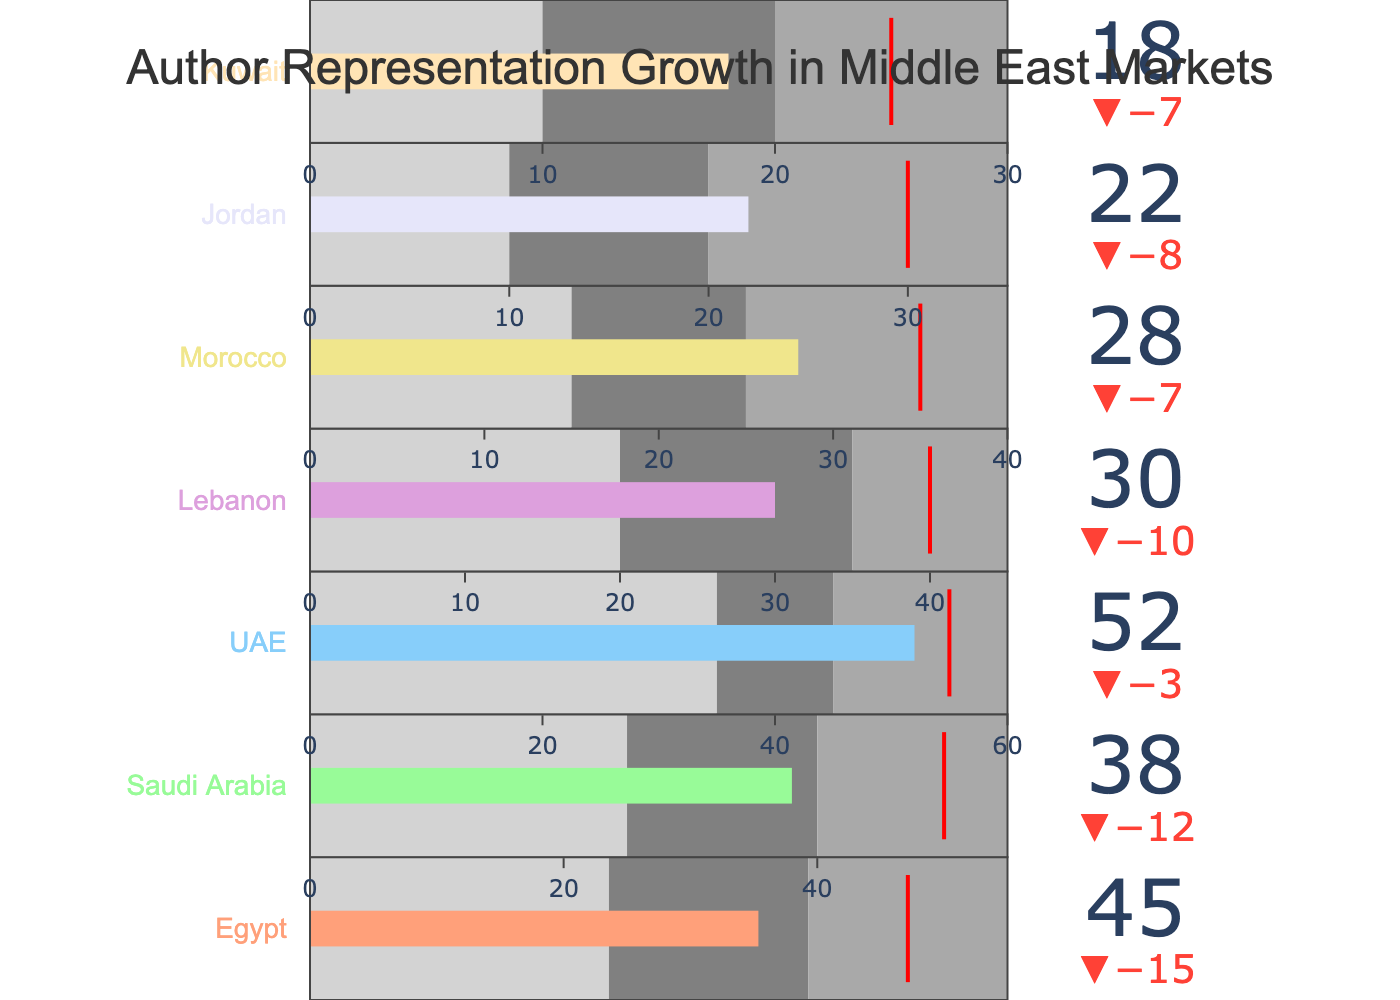What is the title of the bullet chart? The title of the chart is usually displayed at the top and provides information about the overall topic of the chart. In this case, the title tells us what the chart is about.
Answer: Author Representation Growth in Middle East Markets Which country has the highest actual value? By looking at the actual values (the bullet points), we can see which one is the highest among the countries listed.
Answer: UAE What is the target value for Egypt? The target value for each country is shown with a red line or threshold on the bullet chart. For Egypt, this target can be easily located by looking at its section in the chart.
Answer: 60 Which countries have reached their target values? We compare the actual values with the target values for each country. If the actual value is equal to or greater than the target value, the target is considered reached.
Answer: UAE What is the difference between the actual and target values for Saudi Arabia? Subtract Saudi Arabia's actual value from its target value to find the difference.
Answer: 12 How many countries have an actual value greater than 30? Count the number of countries where the actual value exceeds 30.
Answer: 4 Which country has the smallest difference between its actual and target value? Subtract the actual value from the target value for each country and compare these differences to find the smallest one.
Answer: UAE What is the range for the best performance band for Morocco? The chart shows different performance bands, usually represented by different shades of gray. Identify the upper value of the best performance range for Morocco.
Answer: 40 By how much did Jordan fall short of its target? Subtract Jordan's actual value from its target value to find out how much it fell short.
Answer: 8 Compare the range increments (Range1, Range2, Range3) for UAE. Describe how evenly the ranges are distributed. Examine the values given for Range1, Range2, and Range3 for UAE to see if the increments are evenly spaced. If they are evenly distributed, the difference between each consecutive range should be similar.
Answer: Range1: 35, Range2: 45, Range3: 60 (Not evenly distributed because the increments are 10 and 15) 